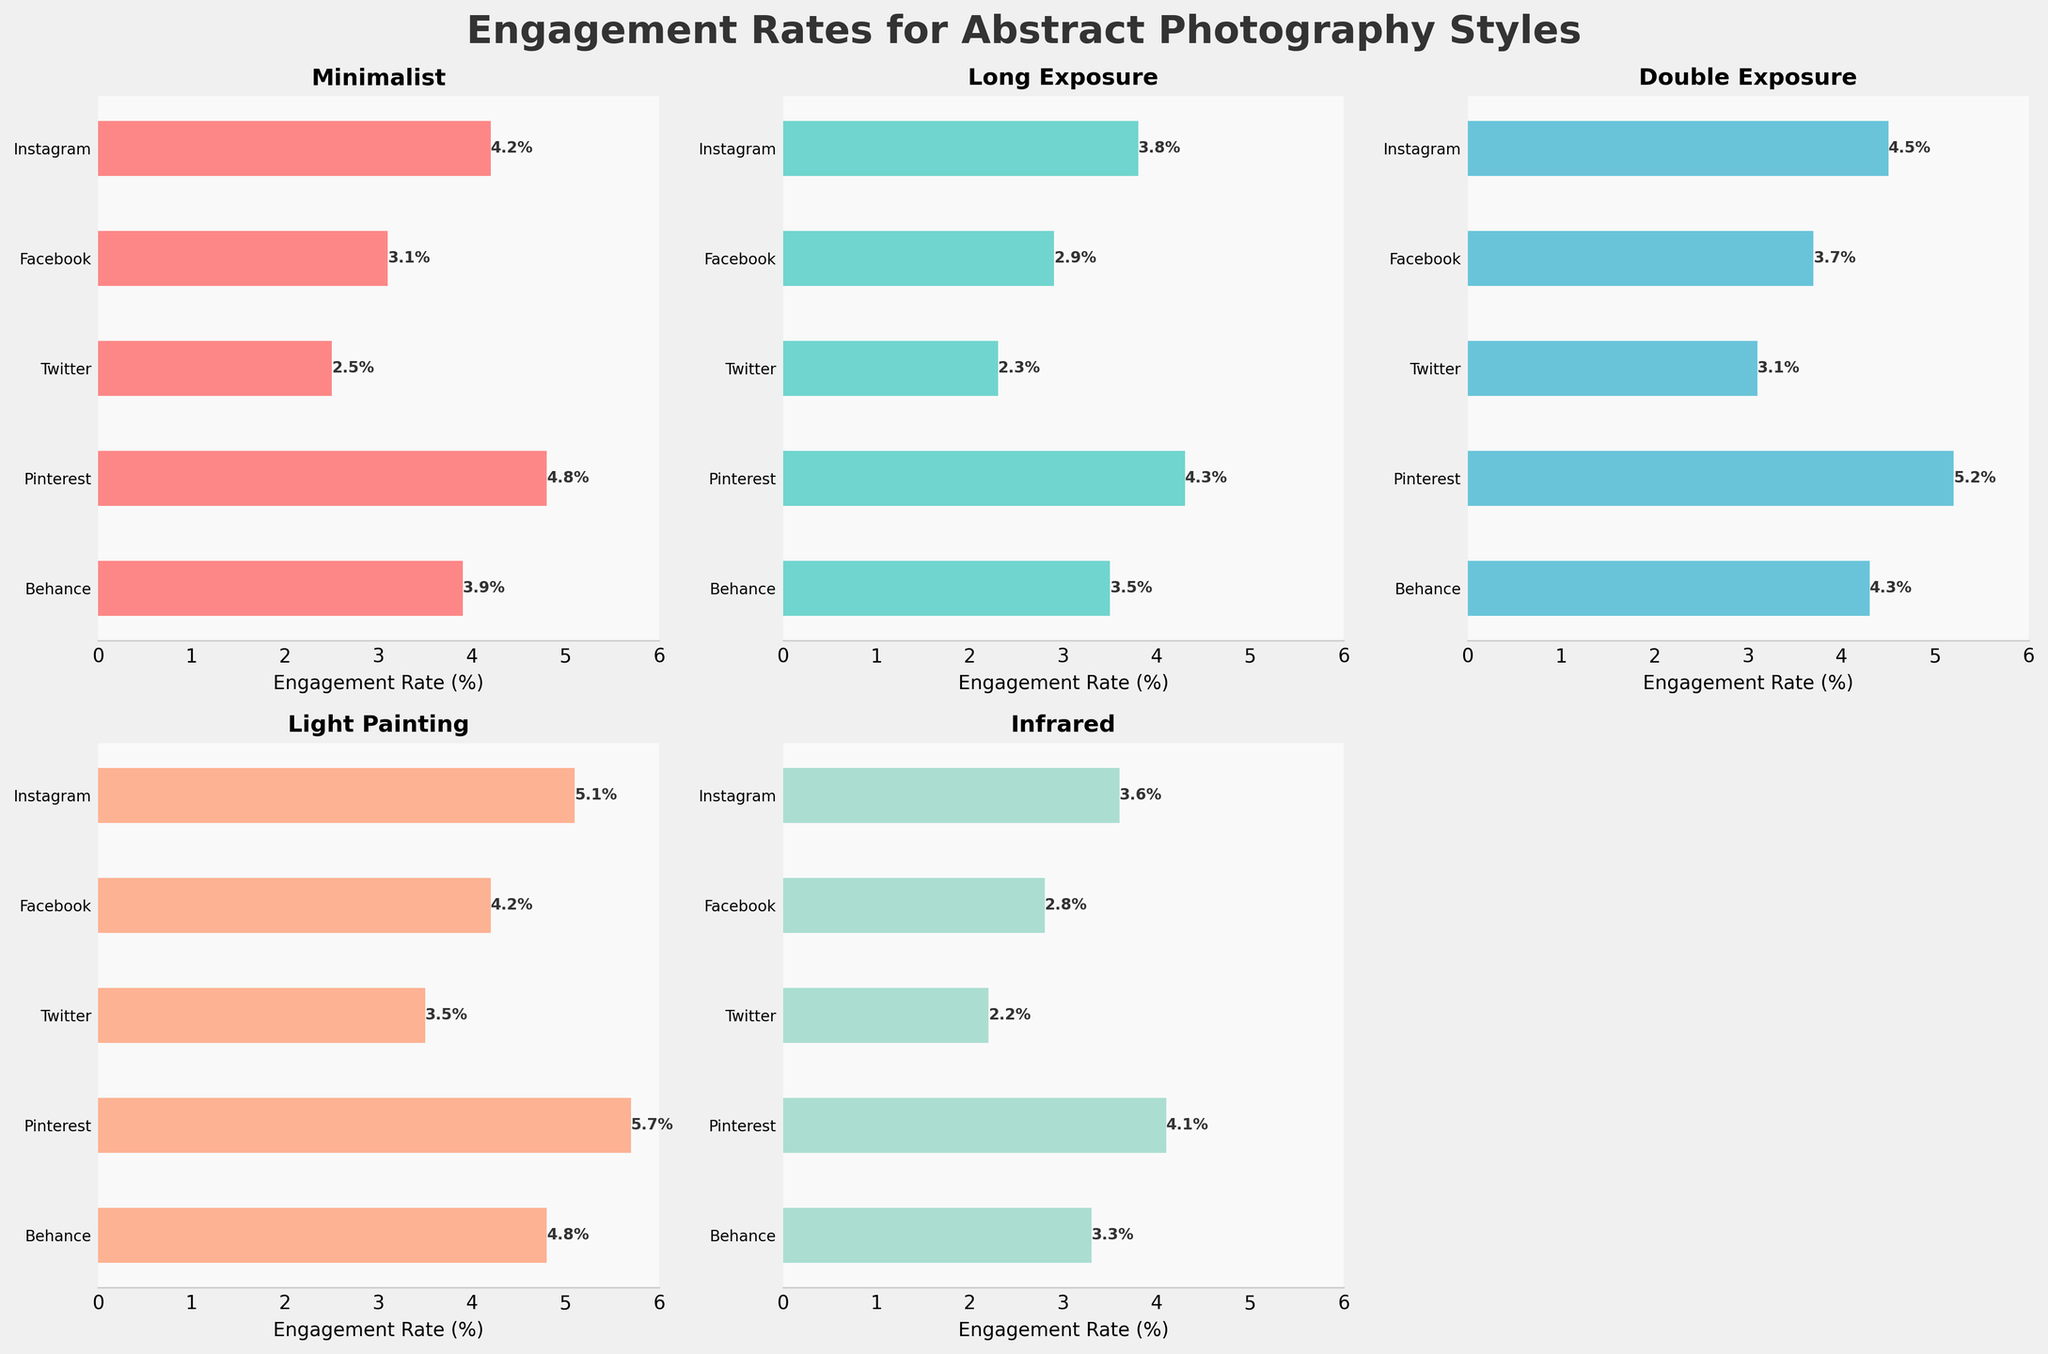What's the title of the figure? The title of the figure is usually located at the top. From the description given, the figure's title is "Engagement Rates for Abstract Photography Styles."
Answer: Engagement Rates for Abstract Photography Styles Which abstract photography style has the highest engagement rate on Instagram? By looking at the Instagram bar charts for each style, the highest engagement rate is for Light Painting at 5.1%.
Answer: Light Painting On Pinterest, how does the engagement rate for Double Exposure compare to Long Exposure? On Pinterest, the engagement rate for Double Exposure is 5.2%, while Long Exposure has a rate of 4.3%. Double Exposure is higher than Long Exposure on Pinterest.
Answer: Double Exposure Which platform has the lowest engagement rate for Infrared photography? By comparing the Infrared engagement rates across platforms, Twitter has the lowest engagement rate at 2.2%.
Answer: Twitter What's the difference between the highest and lowest engagement rates for Minimalist photography across all platforms? The highest engagement rate for Minimalist photography is 4.8% on Pinterest, and the lowest is 2.5% on Twitter. The difference is 4.8 - 2.5 = 2.3%.
Answer: 2.3% Which abstract photography style consistently performs better (has higher engagement rates) across all platforms? By comparing the average engagement rates for each style across all five platforms, Light Painting shows consistently higher engagement rates than other styles.
Answer: Light Painting How does the engagement rate for Light Painting on Behance compare to Instagram? The engagement rate for Light Painting is 4.8% on Behance and 5.1% on Instagram. The rate is slightly higher on Instagram.
Answer: 5.1% is higher Which two platforms have the closest engagement rates for Long Exposure photography? By scanning the bar heights for Long Exposure, Instagram (3.8%) and Pinterest (4.3%) have the closest engagement rates with a difference of 0.5%.
Answer: Instagram and Pinterest What's the average engagement rate for Facebook across all abstract photography styles? Sum the engagement rates for each style on Facebook (3.1 + 2.9 + 3.7 + 4.2 + 2.8) = 16.7. The average engagement rate is 16.7 / 5 = 3.34%.
Answer: 3.34% What is the range of engagement rates for Double Exposure across all platforms? The highest engagement rate for Double Exposure is 5.2% on Pinterest, and the lowest is 3.1% on Twitter, so the range is 5.2 - 3.1 = 2.1%.
Answer: 2.1% 